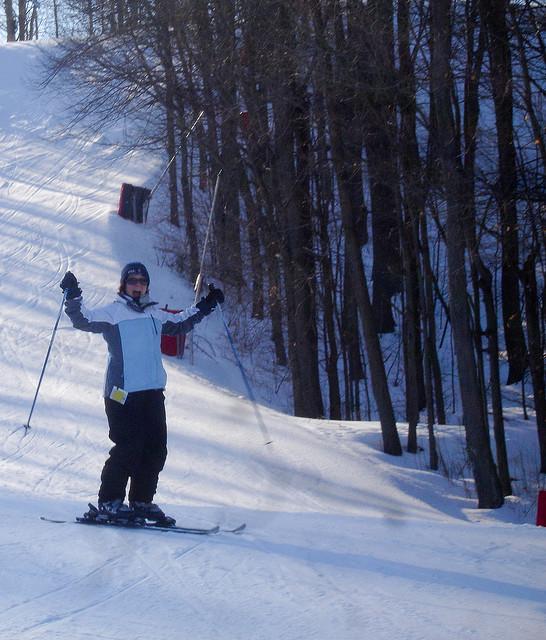Are these trees evergreen?
Give a very brief answer. No. What is the person doing?
Keep it brief. Skiing. What's on the side of the trail?
Keep it brief. Trees. What is white in the photo?
Answer briefly. Snow. What mountain are they on?
Keep it brief. Snowy. Does this person's jacket match her pant's exactly?
Give a very brief answer. No. Is it getting dark?
Give a very brief answer. No. How many people are in the picture?
Concise answer only. 1. Is this downhill skiing?
Keep it brief. Yes. What is on the trees?
Concise answer only. Branches. What color is the woman's jacket?
Concise answer only. White. Is she lifting her left arm?
Short answer required. Yes. What is the man wearing on his head?
Give a very brief answer. Hat. Will the man crash?
Answer briefly. No. Is this a girl skiing?
Short answer required. Yes. Is the woman going uphill?
Give a very brief answer. No. 